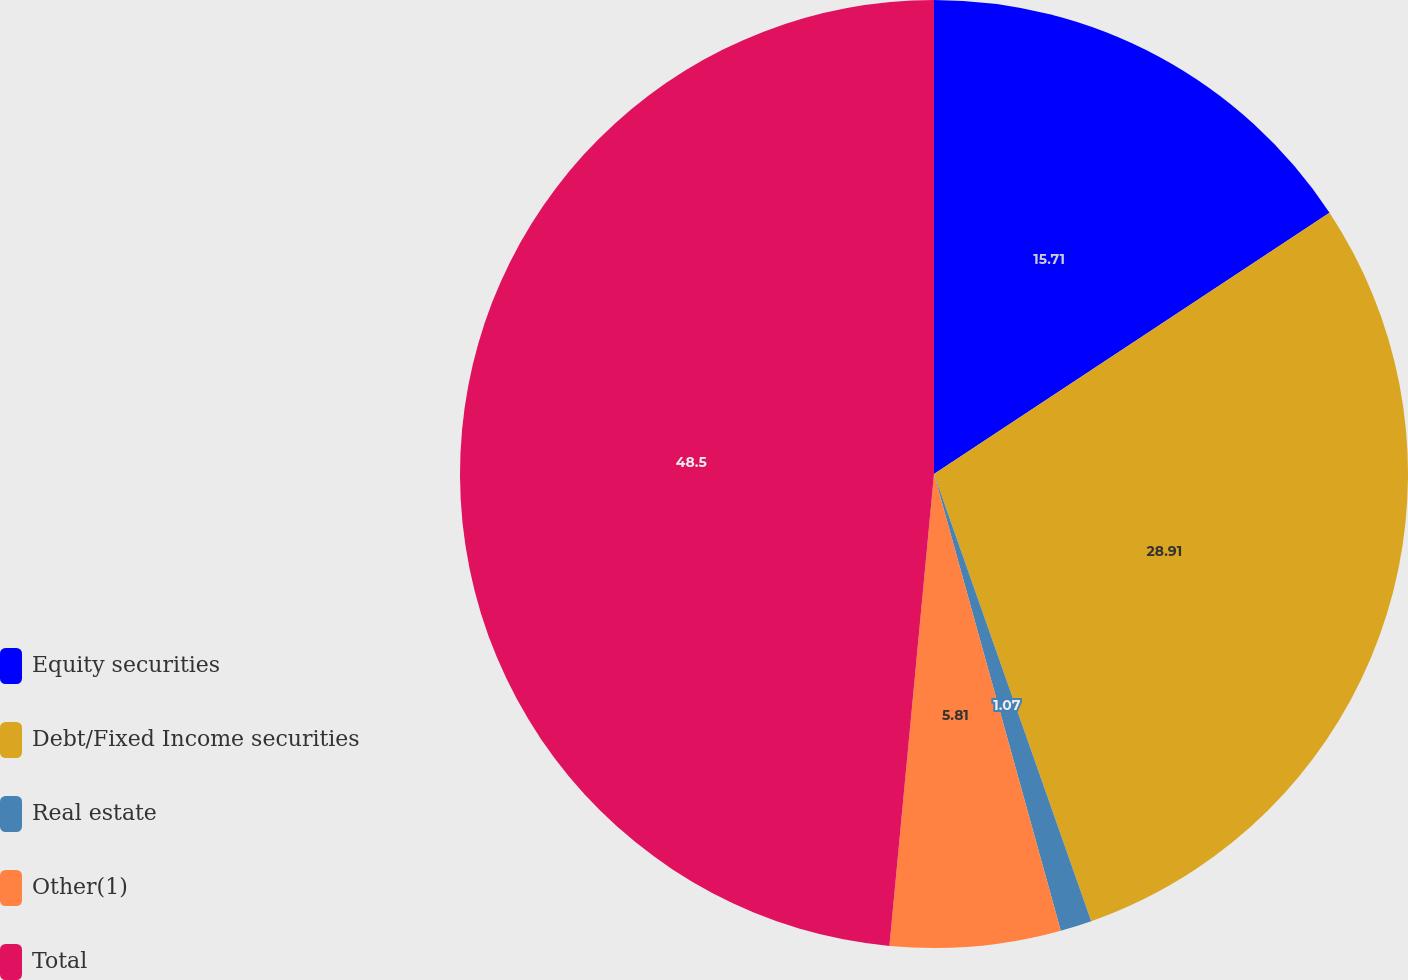Convert chart. <chart><loc_0><loc_0><loc_500><loc_500><pie_chart><fcel>Equity securities<fcel>Debt/Fixed Income securities<fcel>Real estate<fcel>Other(1)<fcel>Total<nl><fcel>15.71%<fcel>28.91%<fcel>1.07%<fcel>5.81%<fcel>48.5%<nl></chart> 